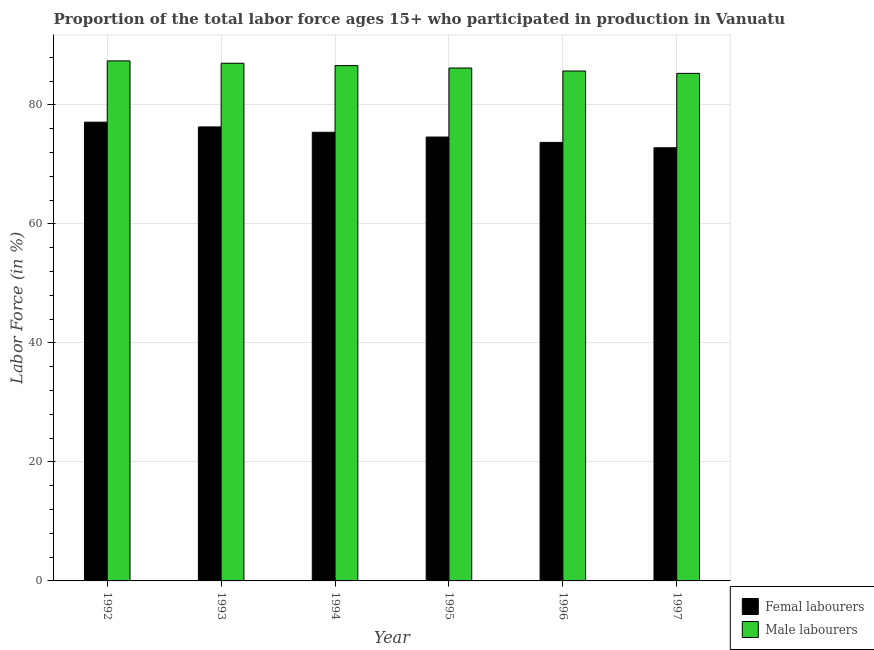How many different coloured bars are there?
Ensure brevity in your answer.  2. How many groups of bars are there?
Keep it short and to the point. 6. Are the number of bars on each tick of the X-axis equal?
Ensure brevity in your answer.  Yes. How many bars are there on the 4th tick from the left?
Keep it short and to the point. 2. How many bars are there on the 4th tick from the right?
Give a very brief answer. 2. What is the label of the 4th group of bars from the left?
Provide a succinct answer. 1995. What is the percentage of female labor force in 1992?
Offer a terse response. 77.1. Across all years, what is the maximum percentage of female labor force?
Offer a terse response. 77.1. Across all years, what is the minimum percentage of female labor force?
Provide a short and direct response. 72.8. In which year was the percentage of male labour force maximum?
Offer a very short reply. 1992. In which year was the percentage of female labor force minimum?
Ensure brevity in your answer.  1997. What is the total percentage of female labor force in the graph?
Ensure brevity in your answer.  449.9. What is the difference between the percentage of male labour force in 1992 and that in 1994?
Provide a succinct answer. 0.8. What is the difference between the percentage of female labor force in 1997 and the percentage of male labour force in 1995?
Your answer should be very brief. -1.8. What is the average percentage of female labor force per year?
Make the answer very short. 74.98. In how many years, is the percentage of male labour force greater than 4 %?
Your answer should be compact. 6. What is the ratio of the percentage of male labour force in 1993 to that in 1995?
Give a very brief answer. 1.01. What is the difference between the highest and the second highest percentage of female labor force?
Your response must be concise. 0.8. What is the difference between the highest and the lowest percentage of male labour force?
Offer a very short reply. 2.1. In how many years, is the percentage of male labour force greater than the average percentage of male labour force taken over all years?
Offer a very short reply. 3. What does the 2nd bar from the left in 1996 represents?
Your answer should be very brief. Male labourers. What does the 2nd bar from the right in 1996 represents?
Offer a terse response. Femal labourers. How many bars are there?
Give a very brief answer. 12. Are all the bars in the graph horizontal?
Offer a very short reply. No. How many years are there in the graph?
Provide a short and direct response. 6. What is the difference between two consecutive major ticks on the Y-axis?
Give a very brief answer. 20. Does the graph contain grids?
Your answer should be very brief. Yes. What is the title of the graph?
Your answer should be very brief. Proportion of the total labor force ages 15+ who participated in production in Vanuatu. What is the label or title of the X-axis?
Provide a short and direct response. Year. What is the Labor Force (in %) of Femal labourers in 1992?
Provide a short and direct response. 77.1. What is the Labor Force (in %) in Male labourers in 1992?
Give a very brief answer. 87.4. What is the Labor Force (in %) in Femal labourers in 1993?
Keep it short and to the point. 76.3. What is the Labor Force (in %) in Femal labourers in 1994?
Offer a terse response. 75.4. What is the Labor Force (in %) of Male labourers in 1994?
Provide a short and direct response. 86.6. What is the Labor Force (in %) of Femal labourers in 1995?
Offer a terse response. 74.6. What is the Labor Force (in %) in Male labourers in 1995?
Ensure brevity in your answer.  86.2. What is the Labor Force (in %) of Femal labourers in 1996?
Your answer should be very brief. 73.7. What is the Labor Force (in %) of Male labourers in 1996?
Your answer should be compact. 85.7. What is the Labor Force (in %) in Femal labourers in 1997?
Offer a terse response. 72.8. What is the Labor Force (in %) of Male labourers in 1997?
Make the answer very short. 85.3. Across all years, what is the maximum Labor Force (in %) in Femal labourers?
Provide a succinct answer. 77.1. Across all years, what is the maximum Labor Force (in %) of Male labourers?
Offer a terse response. 87.4. Across all years, what is the minimum Labor Force (in %) in Femal labourers?
Your answer should be very brief. 72.8. Across all years, what is the minimum Labor Force (in %) of Male labourers?
Your response must be concise. 85.3. What is the total Labor Force (in %) in Femal labourers in the graph?
Your response must be concise. 449.9. What is the total Labor Force (in %) of Male labourers in the graph?
Ensure brevity in your answer.  518.2. What is the difference between the Labor Force (in %) of Femal labourers in 1992 and that in 1993?
Make the answer very short. 0.8. What is the difference between the Labor Force (in %) of Male labourers in 1992 and that in 1993?
Your answer should be compact. 0.4. What is the difference between the Labor Force (in %) of Femal labourers in 1992 and that in 1994?
Make the answer very short. 1.7. What is the difference between the Labor Force (in %) in Male labourers in 1992 and that in 1994?
Offer a very short reply. 0.8. What is the difference between the Labor Force (in %) of Femal labourers in 1992 and that in 1995?
Your answer should be compact. 2.5. What is the difference between the Labor Force (in %) in Male labourers in 1992 and that in 1995?
Give a very brief answer. 1.2. What is the difference between the Labor Force (in %) in Femal labourers in 1992 and that in 1996?
Keep it short and to the point. 3.4. What is the difference between the Labor Force (in %) of Femal labourers in 1992 and that in 1997?
Keep it short and to the point. 4.3. What is the difference between the Labor Force (in %) of Male labourers in 1992 and that in 1997?
Keep it short and to the point. 2.1. What is the difference between the Labor Force (in %) of Femal labourers in 1993 and that in 1994?
Make the answer very short. 0.9. What is the difference between the Labor Force (in %) in Femal labourers in 1993 and that in 1997?
Keep it short and to the point. 3.5. What is the difference between the Labor Force (in %) in Male labourers in 1993 and that in 1997?
Your answer should be very brief. 1.7. What is the difference between the Labor Force (in %) of Femal labourers in 1994 and that in 1996?
Provide a short and direct response. 1.7. What is the difference between the Labor Force (in %) in Femal labourers in 1994 and that in 1997?
Your response must be concise. 2.6. What is the difference between the Labor Force (in %) in Male labourers in 1994 and that in 1997?
Provide a succinct answer. 1.3. What is the difference between the Labor Force (in %) of Femal labourers in 1995 and that in 1996?
Ensure brevity in your answer.  0.9. What is the difference between the Labor Force (in %) of Male labourers in 1995 and that in 1997?
Your answer should be compact. 0.9. What is the difference between the Labor Force (in %) in Male labourers in 1996 and that in 1997?
Offer a terse response. 0.4. What is the difference between the Labor Force (in %) of Femal labourers in 1992 and the Labor Force (in %) of Male labourers in 1994?
Offer a terse response. -9.5. What is the difference between the Labor Force (in %) of Femal labourers in 1992 and the Labor Force (in %) of Male labourers in 1996?
Ensure brevity in your answer.  -8.6. What is the difference between the Labor Force (in %) of Femal labourers in 1992 and the Labor Force (in %) of Male labourers in 1997?
Your answer should be compact. -8.2. What is the difference between the Labor Force (in %) in Femal labourers in 1993 and the Labor Force (in %) in Male labourers in 1995?
Offer a very short reply. -9.9. What is the difference between the Labor Force (in %) of Femal labourers in 1993 and the Labor Force (in %) of Male labourers in 1997?
Your answer should be very brief. -9. What is the difference between the Labor Force (in %) in Femal labourers in 1994 and the Labor Force (in %) in Male labourers in 1995?
Ensure brevity in your answer.  -10.8. What is the difference between the Labor Force (in %) in Femal labourers in 1995 and the Labor Force (in %) in Male labourers in 1996?
Ensure brevity in your answer.  -11.1. What is the average Labor Force (in %) of Femal labourers per year?
Your response must be concise. 74.98. What is the average Labor Force (in %) of Male labourers per year?
Your answer should be compact. 86.37. In the year 1992, what is the difference between the Labor Force (in %) in Femal labourers and Labor Force (in %) in Male labourers?
Offer a terse response. -10.3. In the year 1993, what is the difference between the Labor Force (in %) in Femal labourers and Labor Force (in %) in Male labourers?
Ensure brevity in your answer.  -10.7. In the year 1995, what is the difference between the Labor Force (in %) of Femal labourers and Labor Force (in %) of Male labourers?
Keep it short and to the point. -11.6. In the year 1997, what is the difference between the Labor Force (in %) of Femal labourers and Labor Force (in %) of Male labourers?
Offer a terse response. -12.5. What is the ratio of the Labor Force (in %) of Femal labourers in 1992 to that in 1993?
Keep it short and to the point. 1.01. What is the ratio of the Labor Force (in %) in Femal labourers in 1992 to that in 1994?
Your response must be concise. 1.02. What is the ratio of the Labor Force (in %) of Male labourers in 1992 to that in 1994?
Keep it short and to the point. 1.01. What is the ratio of the Labor Force (in %) of Femal labourers in 1992 to that in 1995?
Provide a succinct answer. 1.03. What is the ratio of the Labor Force (in %) in Male labourers in 1992 to that in 1995?
Offer a very short reply. 1.01. What is the ratio of the Labor Force (in %) of Femal labourers in 1992 to that in 1996?
Provide a short and direct response. 1.05. What is the ratio of the Labor Force (in %) in Male labourers in 1992 to that in 1996?
Your answer should be very brief. 1.02. What is the ratio of the Labor Force (in %) of Femal labourers in 1992 to that in 1997?
Ensure brevity in your answer.  1.06. What is the ratio of the Labor Force (in %) in Male labourers in 1992 to that in 1997?
Provide a succinct answer. 1.02. What is the ratio of the Labor Force (in %) of Femal labourers in 1993 to that in 1994?
Provide a short and direct response. 1.01. What is the ratio of the Labor Force (in %) in Male labourers in 1993 to that in 1994?
Your answer should be compact. 1. What is the ratio of the Labor Force (in %) in Femal labourers in 1993 to that in 1995?
Offer a terse response. 1.02. What is the ratio of the Labor Force (in %) of Male labourers in 1993 to that in 1995?
Ensure brevity in your answer.  1.01. What is the ratio of the Labor Force (in %) in Femal labourers in 1993 to that in 1996?
Offer a terse response. 1.04. What is the ratio of the Labor Force (in %) in Male labourers in 1993 to that in 1996?
Provide a short and direct response. 1.02. What is the ratio of the Labor Force (in %) of Femal labourers in 1993 to that in 1997?
Ensure brevity in your answer.  1.05. What is the ratio of the Labor Force (in %) in Male labourers in 1993 to that in 1997?
Your answer should be compact. 1.02. What is the ratio of the Labor Force (in %) of Femal labourers in 1994 to that in 1995?
Make the answer very short. 1.01. What is the ratio of the Labor Force (in %) of Femal labourers in 1994 to that in 1996?
Your answer should be compact. 1.02. What is the ratio of the Labor Force (in %) in Male labourers in 1994 to that in 1996?
Your response must be concise. 1.01. What is the ratio of the Labor Force (in %) in Femal labourers in 1994 to that in 1997?
Offer a very short reply. 1.04. What is the ratio of the Labor Force (in %) of Male labourers in 1994 to that in 1997?
Offer a terse response. 1.02. What is the ratio of the Labor Force (in %) in Femal labourers in 1995 to that in 1996?
Provide a succinct answer. 1.01. What is the ratio of the Labor Force (in %) in Male labourers in 1995 to that in 1996?
Provide a succinct answer. 1.01. What is the ratio of the Labor Force (in %) of Femal labourers in 1995 to that in 1997?
Offer a terse response. 1.02. What is the ratio of the Labor Force (in %) of Male labourers in 1995 to that in 1997?
Keep it short and to the point. 1.01. What is the ratio of the Labor Force (in %) of Femal labourers in 1996 to that in 1997?
Offer a terse response. 1.01. What is the ratio of the Labor Force (in %) of Male labourers in 1996 to that in 1997?
Offer a terse response. 1. What is the difference between the highest and the second highest Labor Force (in %) of Femal labourers?
Ensure brevity in your answer.  0.8. What is the difference between the highest and the second highest Labor Force (in %) in Male labourers?
Offer a terse response. 0.4. What is the difference between the highest and the lowest Labor Force (in %) in Male labourers?
Keep it short and to the point. 2.1. 